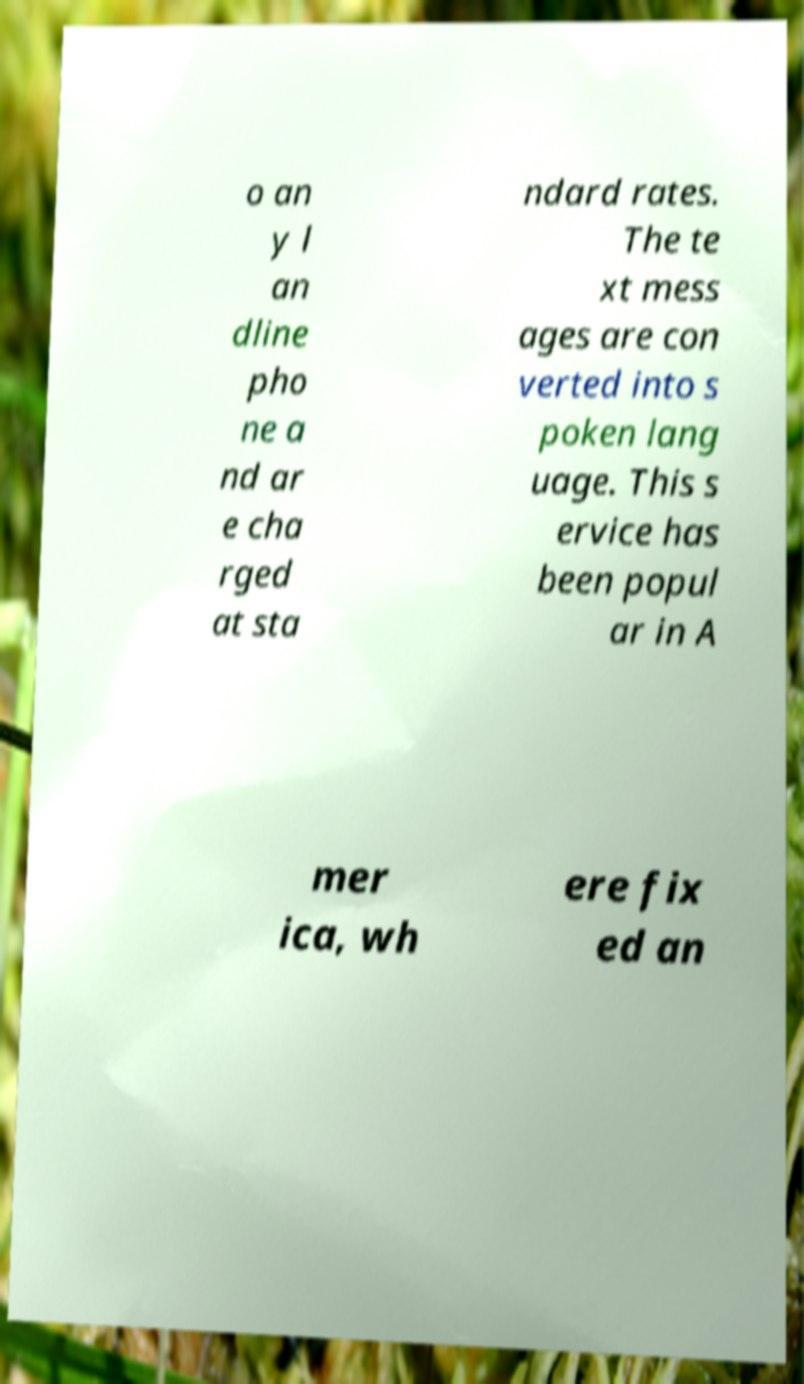There's text embedded in this image that I need extracted. Can you transcribe it verbatim? o an y l an dline pho ne a nd ar e cha rged at sta ndard rates. The te xt mess ages are con verted into s poken lang uage. This s ervice has been popul ar in A mer ica, wh ere fix ed an 